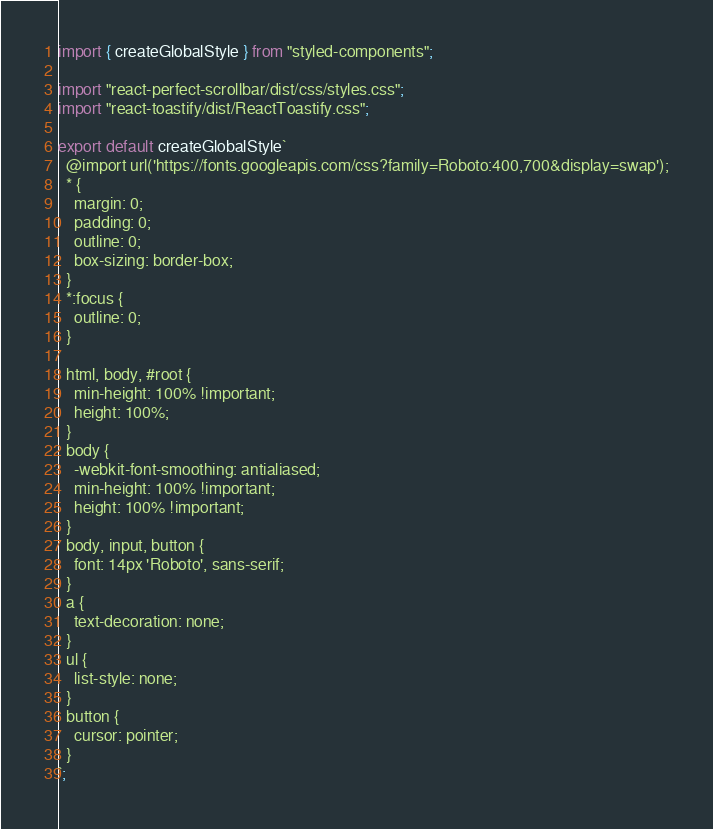Convert code to text. <code><loc_0><loc_0><loc_500><loc_500><_JavaScript_>import { createGlobalStyle } from "styled-components";

import "react-perfect-scrollbar/dist/css/styles.css";
import "react-toastify/dist/ReactToastify.css";

export default createGlobalStyle`
  @import url('https://fonts.googleapis.com/css?family=Roboto:400,700&display=swap');
  * {
    margin: 0;
    padding: 0;
    outline: 0;
    box-sizing: border-box;
  }
  *:focus {
    outline: 0;
  }

  html, body, #root {
    min-height: 100% !important;
    height: 100%;
  }
  body {
    -webkit-font-smoothing: antialiased;
    min-height: 100% !important;
    height: 100% !important;
  }
  body, input, button {
    font: 14px 'Roboto', sans-serif;
  }
  a {
    text-decoration: none;
  }
  ul {
    list-style: none;
  }
  button {
    cursor: pointer;
  }
`;
</code> 